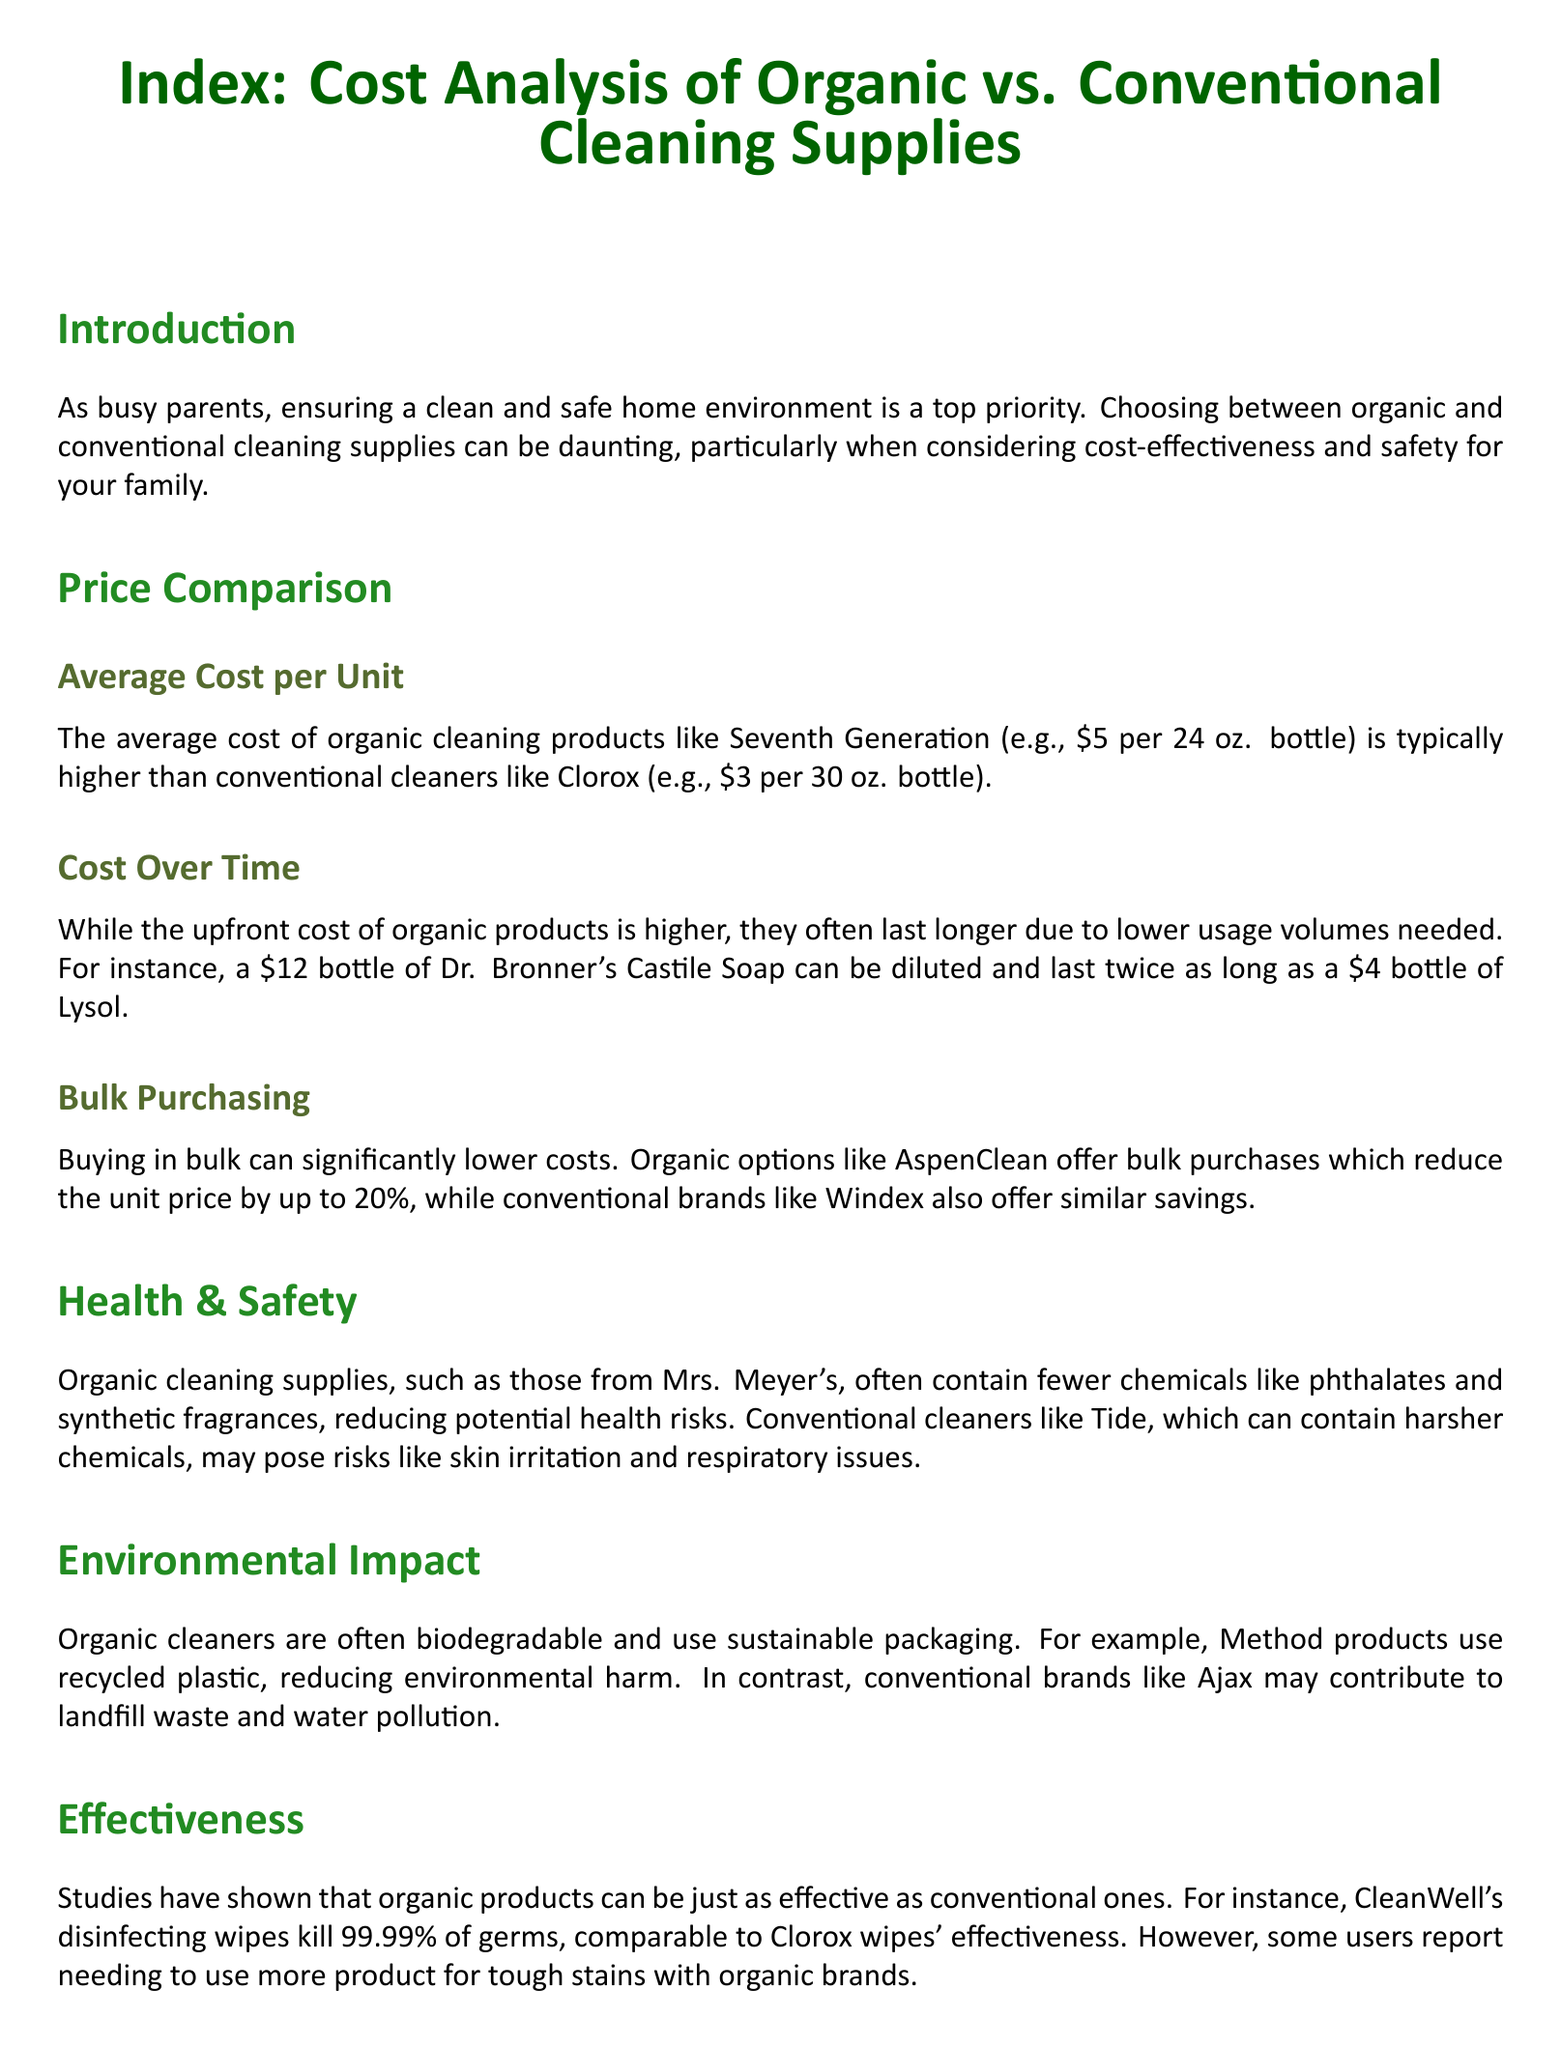what is the average cost of organic cleaning products mentioned? The document states that the average cost of organic cleaning products, like Seventh Generation, is about $5 per 24 oz. bottle.
Answer: $5 what is the average cost of conventional cleaners listed? The average cost for conventional cleaners, such as Clorox, is indicated as $3 per 30 oz. bottle.
Answer: $3 how much can bulk purchasing reduce the unit price for organic options? The document mentions that buying in bulk can reduce the unit price by up to 20% for organic options like AspenClean.
Answer: 20% what chemical is mentioned as being contained in conventional cleaners that may pose health risks? The document identifies phthalates as a chemical found in conventional cleaners that may pose health risks.
Answer: phthalates which organic product is cited for being diluted and lasting longer? Dr. Bronner's Castile Soap is referenced as an organic product that can be diluted and last longer than typical cleaners.
Answer: Dr. Bronner's Castile Soap what percentage of germs do CleanWell's disinfecting wipes kill? The document states that CleanWell's disinfecting wipes kill 99.99% of germs.
Answer: 99.99% which brand is noted for its environmentally friendly packaging? Method products are highlighted for using recycled plastic in their packaging, making them environmentally friendly.
Answer: Method what is the main concern for busy parents when choosing cleaning supplies? The primary concern for busy parents is maintaining a clean and safe home environment.
Answer: clean and safe home environment what factor do parents appreciate about conventional cleaners like Scrubbing Bubbles? The document mentions that parents appreciate the ease-of-use of conventional cleaners like Scrubbing Bubbles.
Answer: ease-of-use 